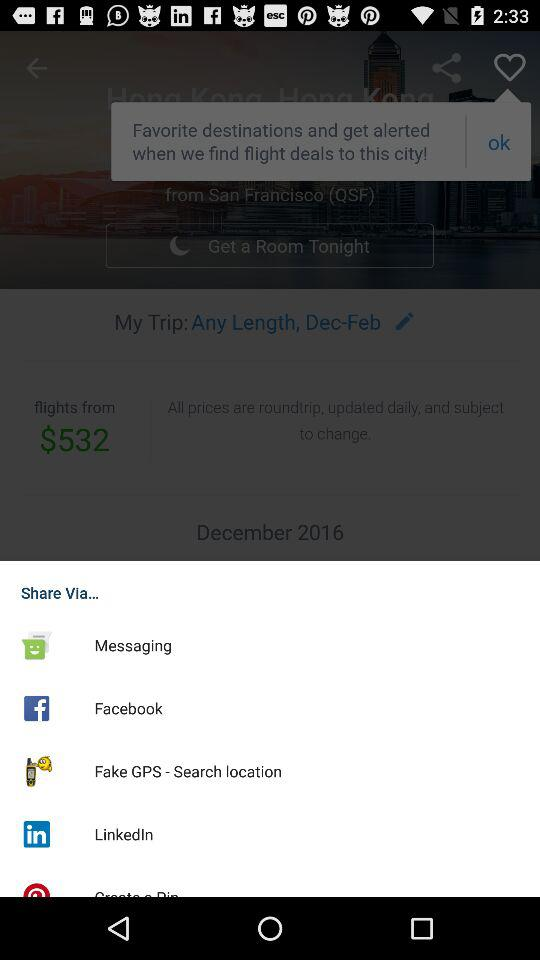How many days does the trip last?
Answer the question using a single word or phrase. Any Length 